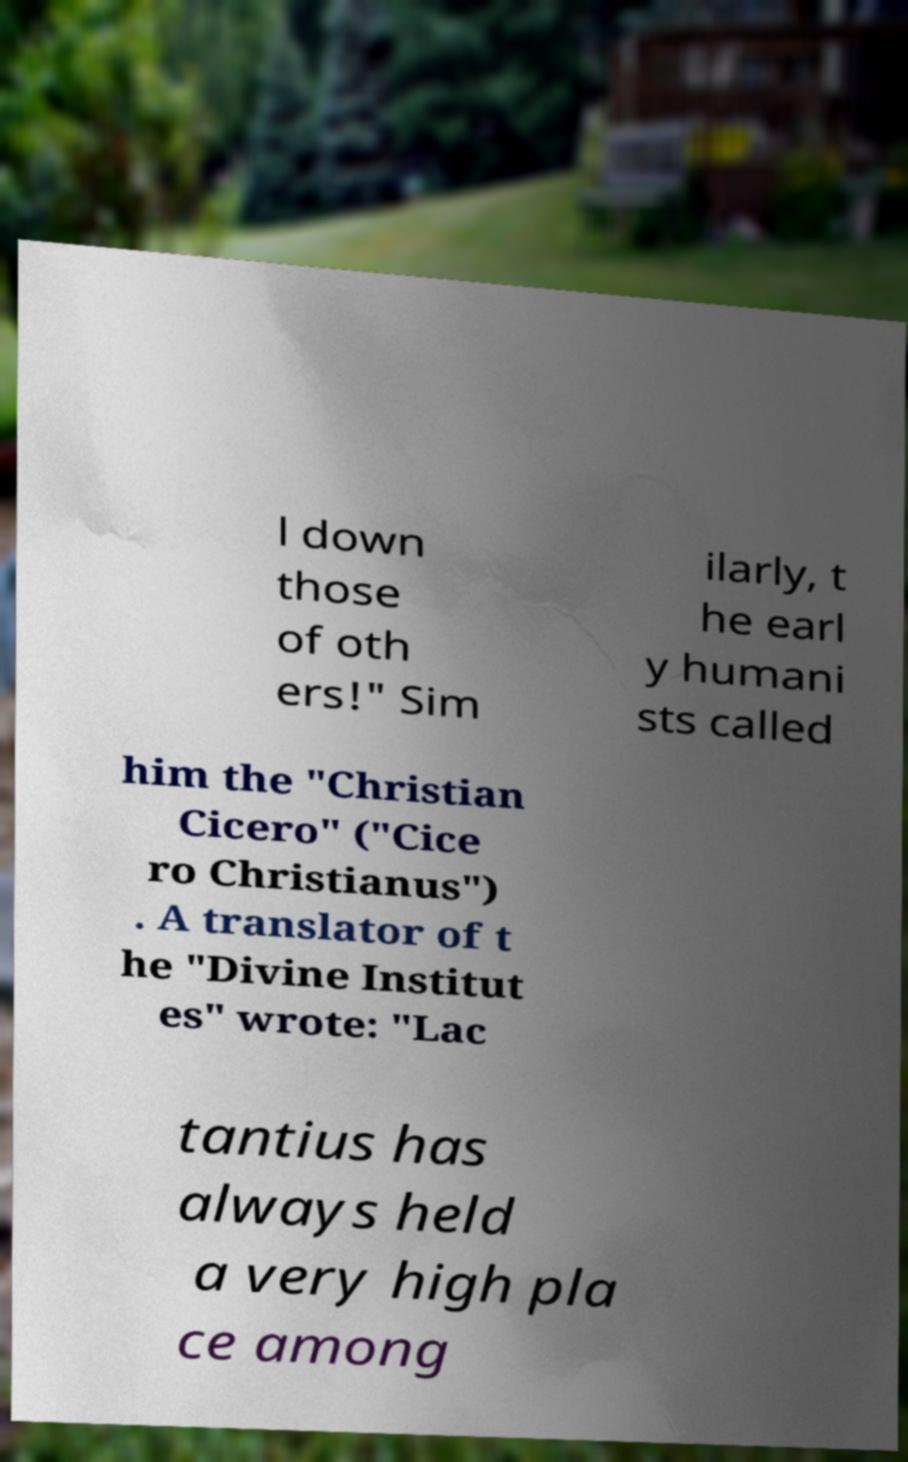For documentation purposes, I need the text within this image transcribed. Could you provide that? l down those of oth ers!" Sim ilarly, t he earl y humani sts called him the "Christian Cicero" ("Cice ro Christianus") . A translator of t he "Divine Institut es" wrote: "Lac tantius has always held a very high pla ce among 